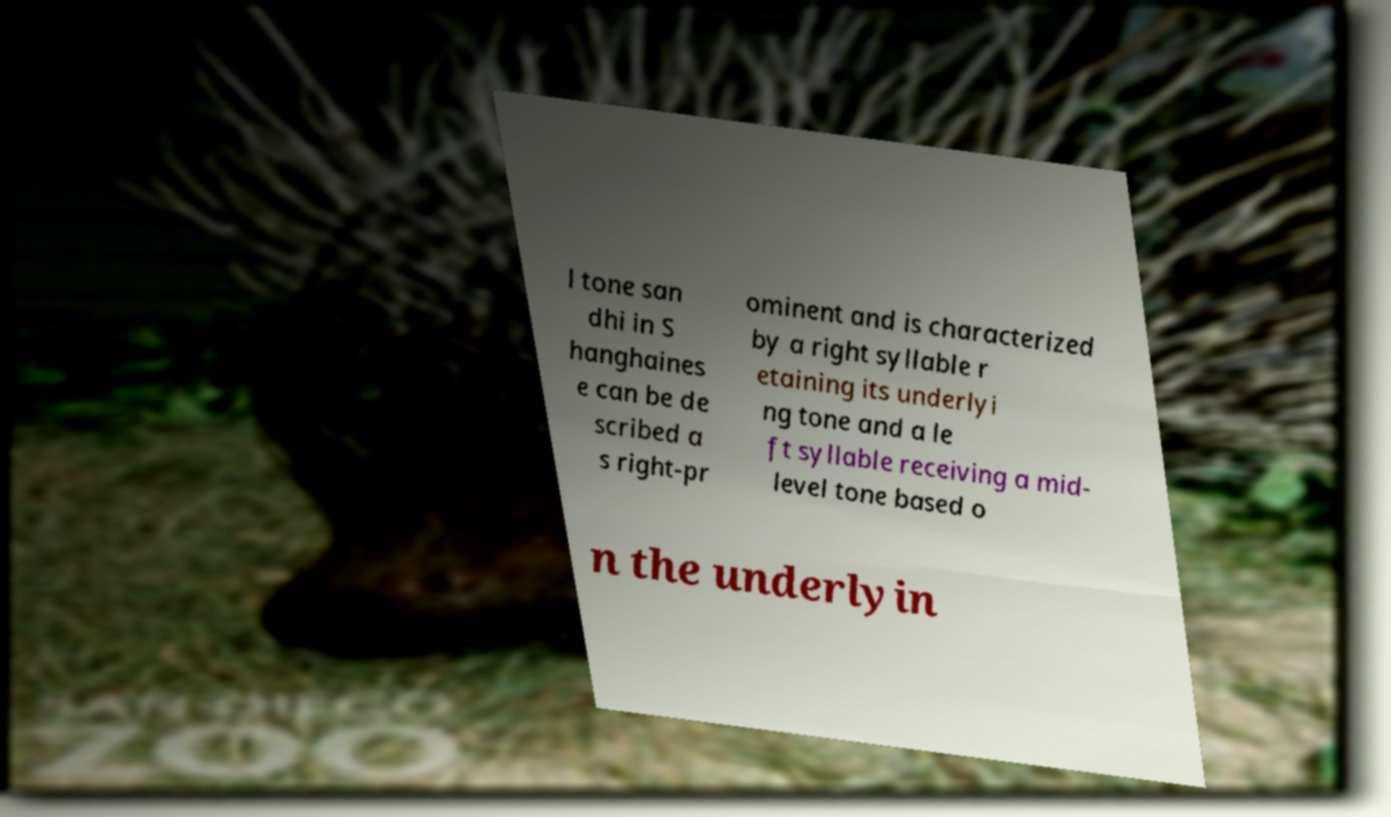Can you read and provide the text displayed in the image?This photo seems to have some interesting text. Can you extract and type it out for me? l tone san dhi in S hanghaines e can be de scribed a s right-pr ominent and is characterized by a right syllable r etaining its underlyi ng tone and a le ft syllable receiving a mid- level tone based o n the underlyin 